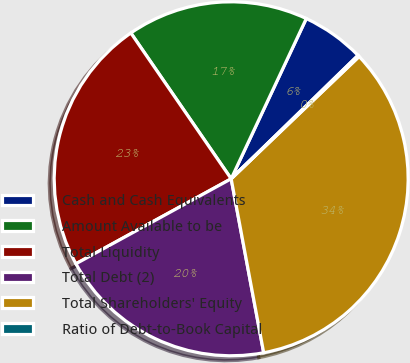Convert chart to OTSL. <chart><loc_0><loc_0><loc_500><loc_500><pie_chart><fcel>Cash and Cash Equivalents<fcel>Amount Available to be<fcel>Total Liquidity<fcel>Total Debt (2)<fcel>Total Shareholders' Equity<fcel>Ratio of Debt-to-Book Capital<nl><fcel>5.74%<fcel>16.57%<fcel>23.38%<fcel>19.97%<fcel>34.2%<fcel>0.14%<nl></chart> 